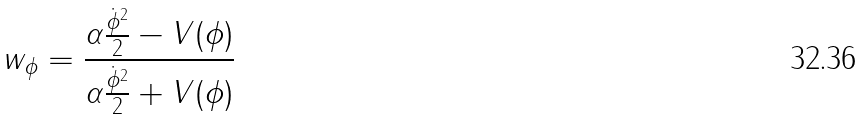Convert formula to latex. <formula><loc_0><loc_0><loc_500><loc_500>w _ { \phi } = \frac { \alpha \frac { \dot { \phi } ^ { 2 } } { 2 } - V ( \phi ) } { \alpha \frac { \dot { \phi } ^ { 2 } } { 2 } + V ( \phi ) }</formula> 